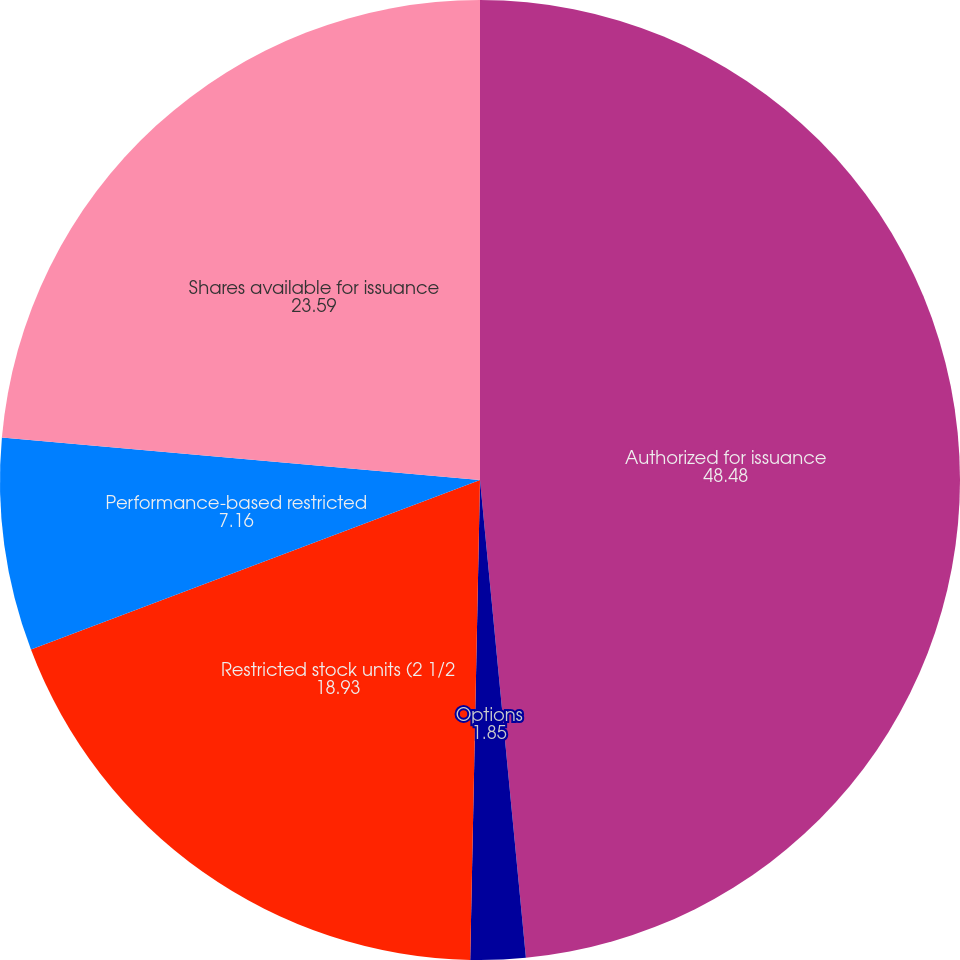Convert chart. <chart><loc_0><loc_0><loc_500><loc_500><pie_chart><fcel>Authorized for issuance<fcel>Options<fcel>Restricted stock units (2 1/2<fcel>Performance-based restricted<fcel>Shares available for issuance<nl><fcel>48.48%<fcel>1.85%<fcel>18.93%<fcel>7.16%<fcel>23.59%<nl></chart> 